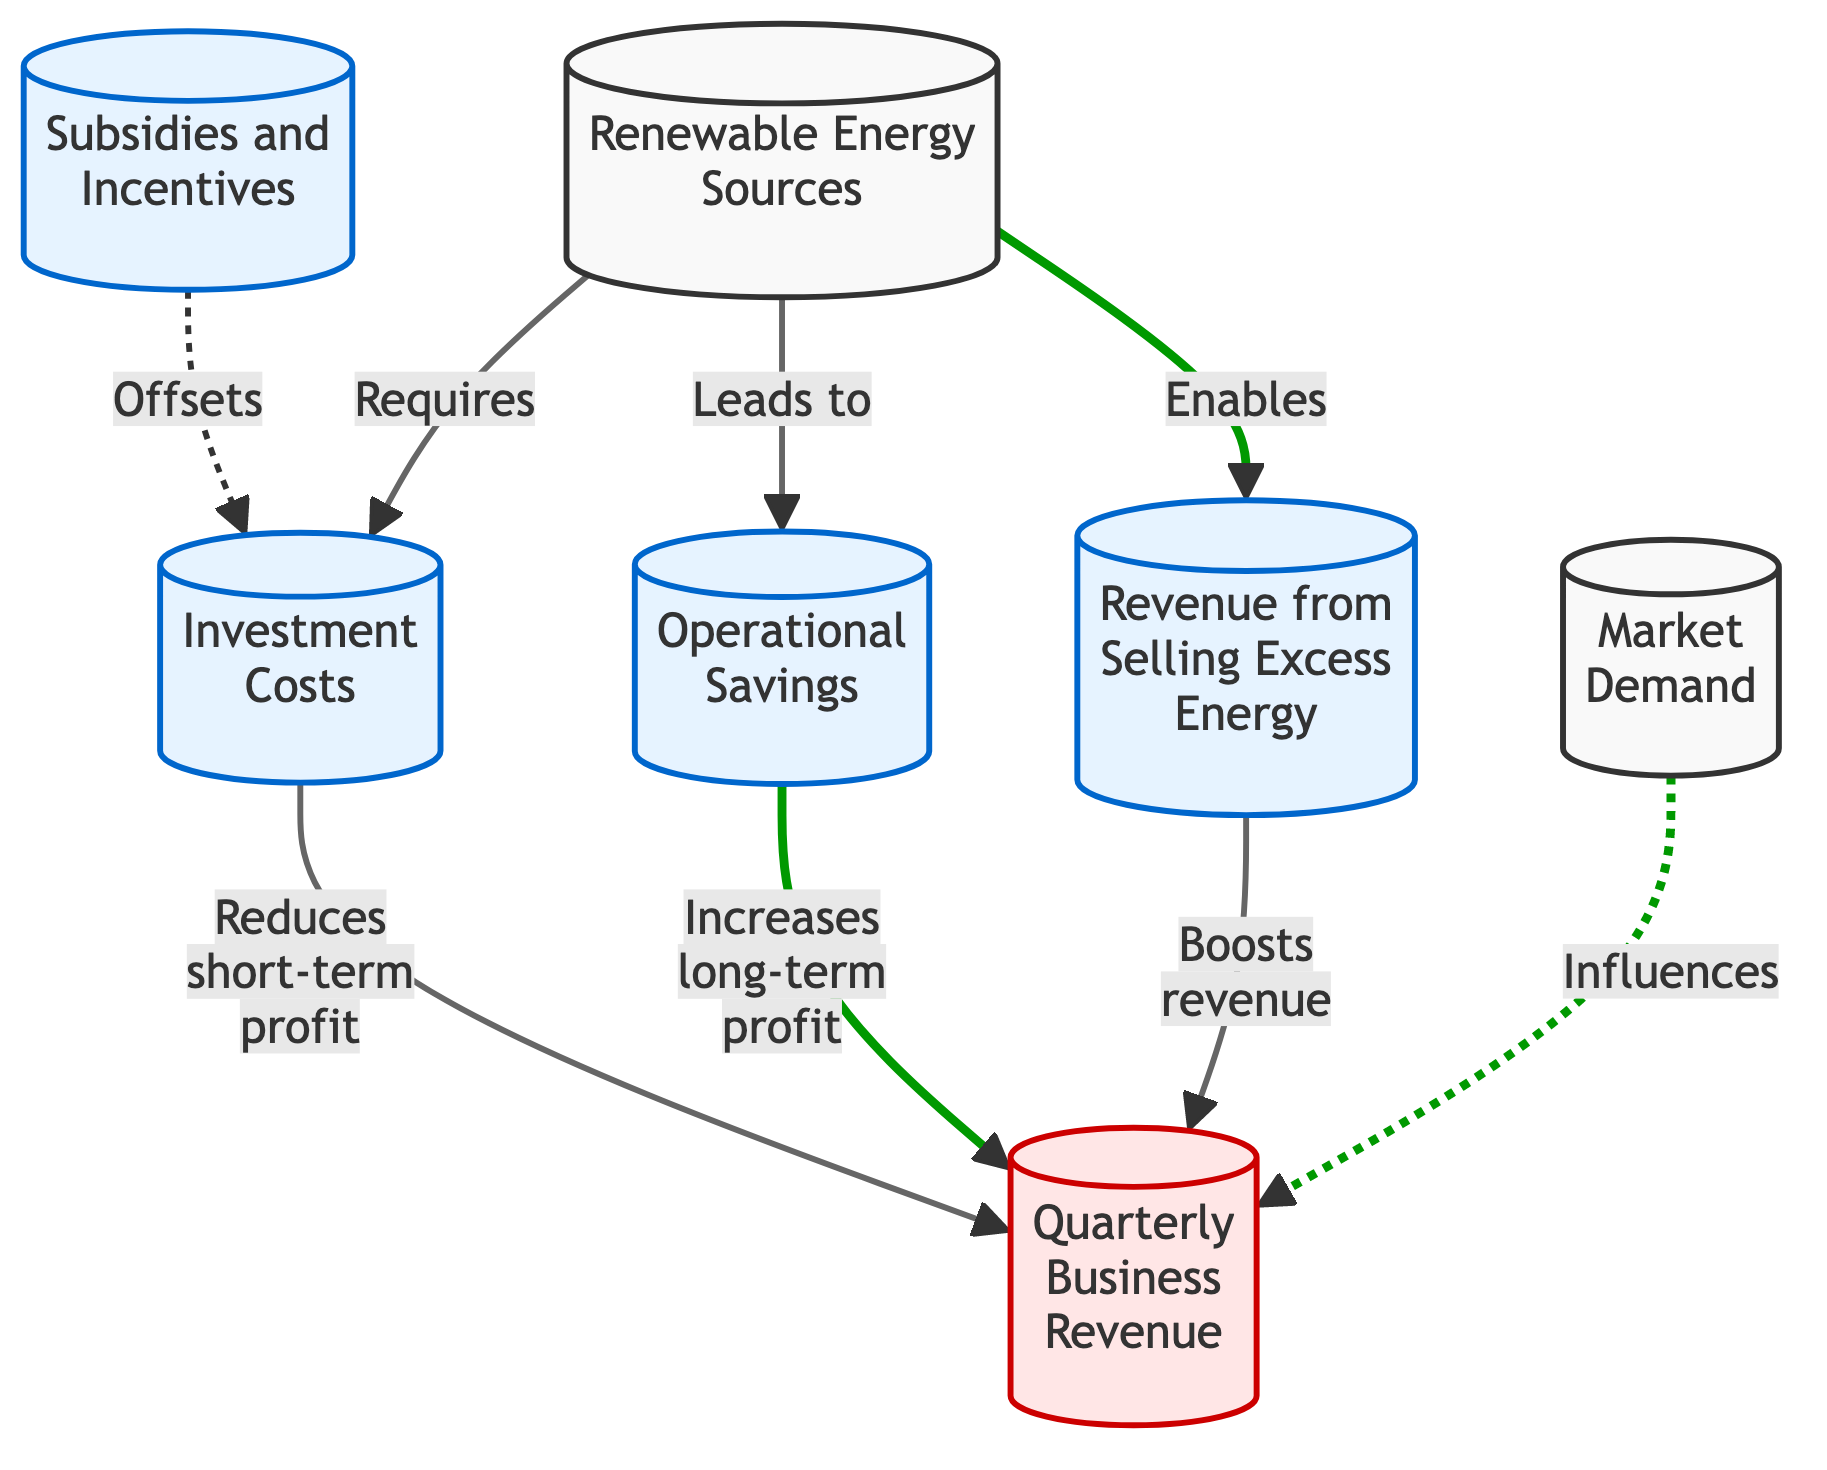What is the first node in the diagram? The first node in the diagram is "Renewable Energy Sources," as it is the starting point of the flow that connects to other nodes.
Answer: Renewable Energy Sources How many nodes are in the diagram? By counting the nodes visually represented in the diagram, we find there are a total of 7 nodes.
Answer: 7 What is the relationship between "Operational Savings" and "Quarterly Business Revenue"? "Operational Savings" leads to an increase in "Quarterly Business Revenue," indicating a positive relationship where savings contribute to higher revenue over time.
Answer: Increases long-term profit How does "Investment Costs" affect "Quarterly Business Revenue"? "Investment Costs" directly reduces the short-term profit, which negatively affects "Quarterly Business Revenue" in the immediate term.
Answer: Reduces short-term profit Which node enables revenue from selling excess energy? The node "Renewable Energy Sources" enables the revenue from selling excess energy, demonstrating that investing in renewable sources can create additional income streams.
Answer: Renewable Energy Sources What influences "Quarterly Business Revenue"? "Market Demand" influences "Quarterly Business Revenue," showing that the demand in the marketplace can have an impact on how much revenue a business generates.
Answer: Influences Which nodes contribute positively to "Quarterly Business Revenue"? The nodes "Operational Savings" and "Revenue from Selling Excess Energy" both contribute positively to "Quarterly Business Revenue," indicating they enhance profit earned over time.
Answer: Operational Savings, Revenue from Selling Excess Energy What effect do subsidies and incentives have on investment costs? Subsidies and incentives offset "Investment Costs," reducing the financial burden of investing in renewable energy sources for businesses.
Answer: Offsets Which node has the highest stroke weight in the diagram? The nodes connected to "Operational Savings," "Revenue from Selling Excess Energy," and "Market Demand" all have a stroke weight indicating their direct positive influence, but they are visually similar in thickness with emphasis on positive contributions.
Answer: Three nodes have equal weight 